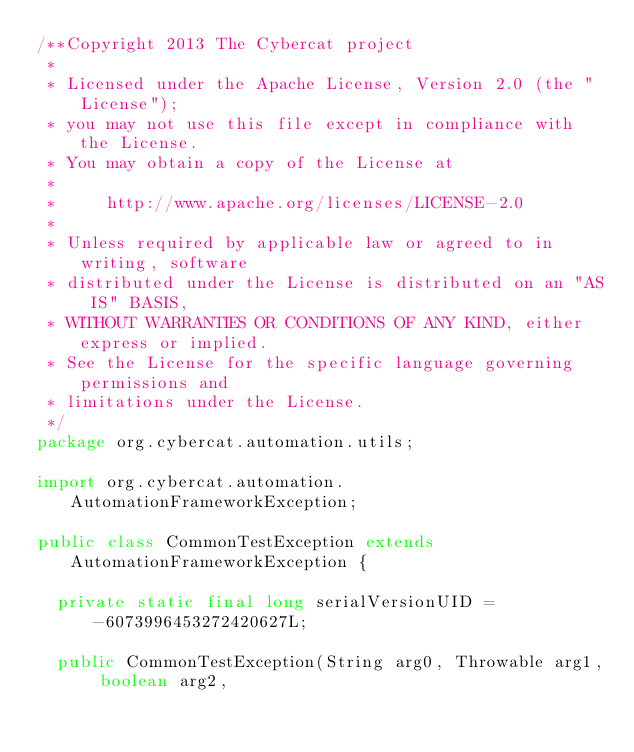<code> <loc_0><loc_0><loc_500><loc_500><_Java_>/**Copyright 2013 The Cybercat project
 * 
 * Licensed under the Apache License, Version 2.0 (the "License");
 * you may not use this file except in compliance with the License.
 * You may obtain a copy of the License at
 * 
 *     http://www.apache.org/licenses/LICENSE-2.0
 *     
 * Unless required by applicable law or agreed to in writing, software
 * distributed under the License is distributed on an "AS IS" BASIS,
 * WITHOUT WARRANTIES OR CONDITIONS OF ANY KIND, either express or implied.
 * See the License for the specific language governing permissions and
 * limitations under the License.
 */
package org.cybercat.automation.utils;

import org.cybercat.automation.AutomationFrameworkException;

public class CommonTestException extends AutomationFrameworkException {

	private static final long serialVersionUID = -6073996453272420627L;

	public CommonTestException(String arg0, Throwable arg1, boolean arg2,</code> 